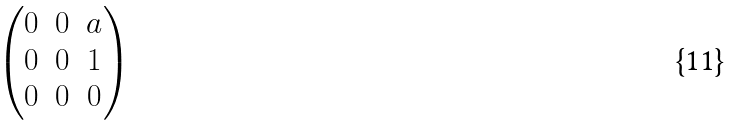Convert formula to latex. <formula><loc_0><loc_0><loc_500><loc_500>\begin{pmatrix} 0 & 0 & a \\ 0 & 0 & 1 \\ 0 & 0 & 0 \end{pmatrix}</formula> 